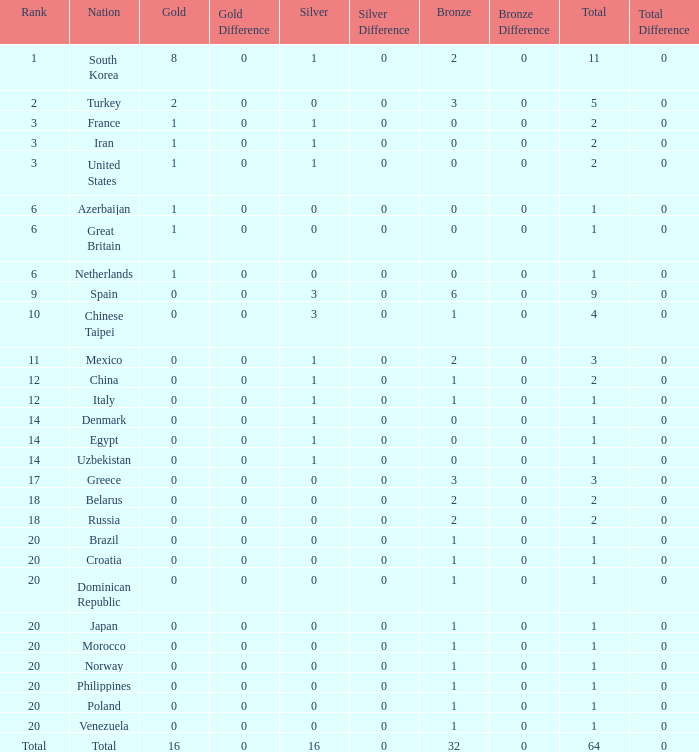What is the average number of bronze of the nation with more than 1 gold and 1 silver medal? 2.0. 